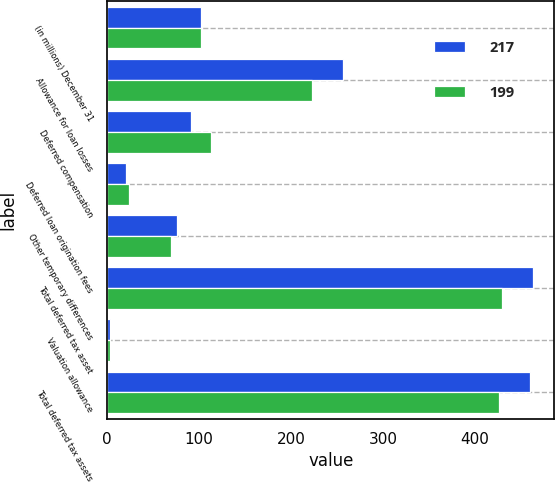Convert chart. <chart><loc_0><loc_0><loc_500><loc_500><stacked_bar_chart><ecel><fcel>(in millions) December 31<fcel>Allowance for loan losses<fcel>Deferred compensation<fcel>Deferred loan origination fees<fcel>Other temporary differences<fcel>Total deferred tax asset<fcel>Valuation allowance<fcel>Total deferred tax assets<nl><fcel>217<fcel>102<fcel>256<fcel>91<fcel>20<fcel>76<fcel>463<fcel>3<fcel>460<nl><fcel>199<fcel>102<fcel>223<fcel>113<fcel>24<fcel>69<fcel>429<fcel>3<fcel>426<nl></chart> 